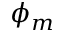Convert formula to latex. <formula><loc_0><loc_0><loc_500><loc_500>\phi _ { m }</formula> 